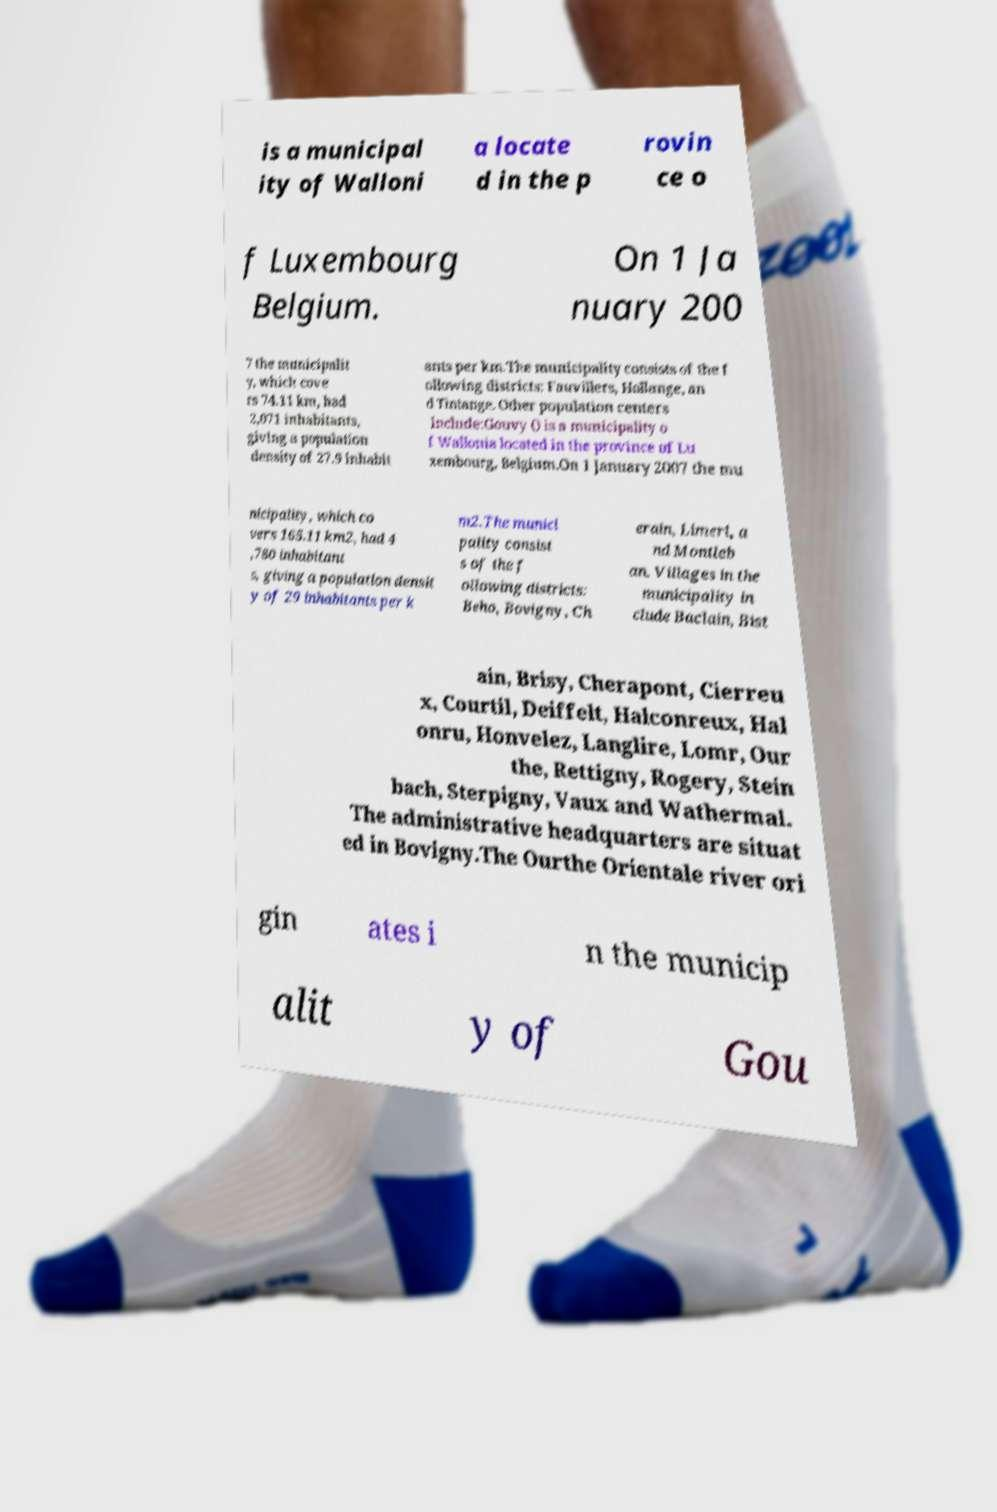I need the written content from this picture converted into text. Can you do that? is a municipal ity of Walloni a locate d in the p rovin ce o f Luxembourg Belgium. On 1 Ja nuary 200 7 the municipalit y, which cove rs 74.11 km, had 2,071 inhabitants, giving a population density of 27.9 inhabit ants per km.The municipality consists of the f ollowing districts: Fauvillers, Hollange, an d Tintange. Other population centers include:Gouvy () is a municipality o f Wallonia located in the province of Lu xembourg, Belgium.On 1 January 2007 the mu nicipality, which co vers 165.11 km2, had 4 ,780 inhabitant s, giving a population densit y of 29 inhabitants per k m2.The munici pality consist s of the f ollowing districts: Beho, Bovigny, Ch erain, Limerl, a nd Montleb an. Villages in the municipality in clude Baclain, Bist ain, Brisy, Cherapont, Cierreu x, Courtil, Deiffelt, Halconreux, Hal onru, Honvelez, Langlire, Lomr, Our the, Rettigny, Rogery, Stein bach, Sterpigny, Vaux and Wathermal. The administrative headquarters are situat ed in Bovigny.The Ourthe Orientale river ori gin ates i n the municip alit y of Gou 